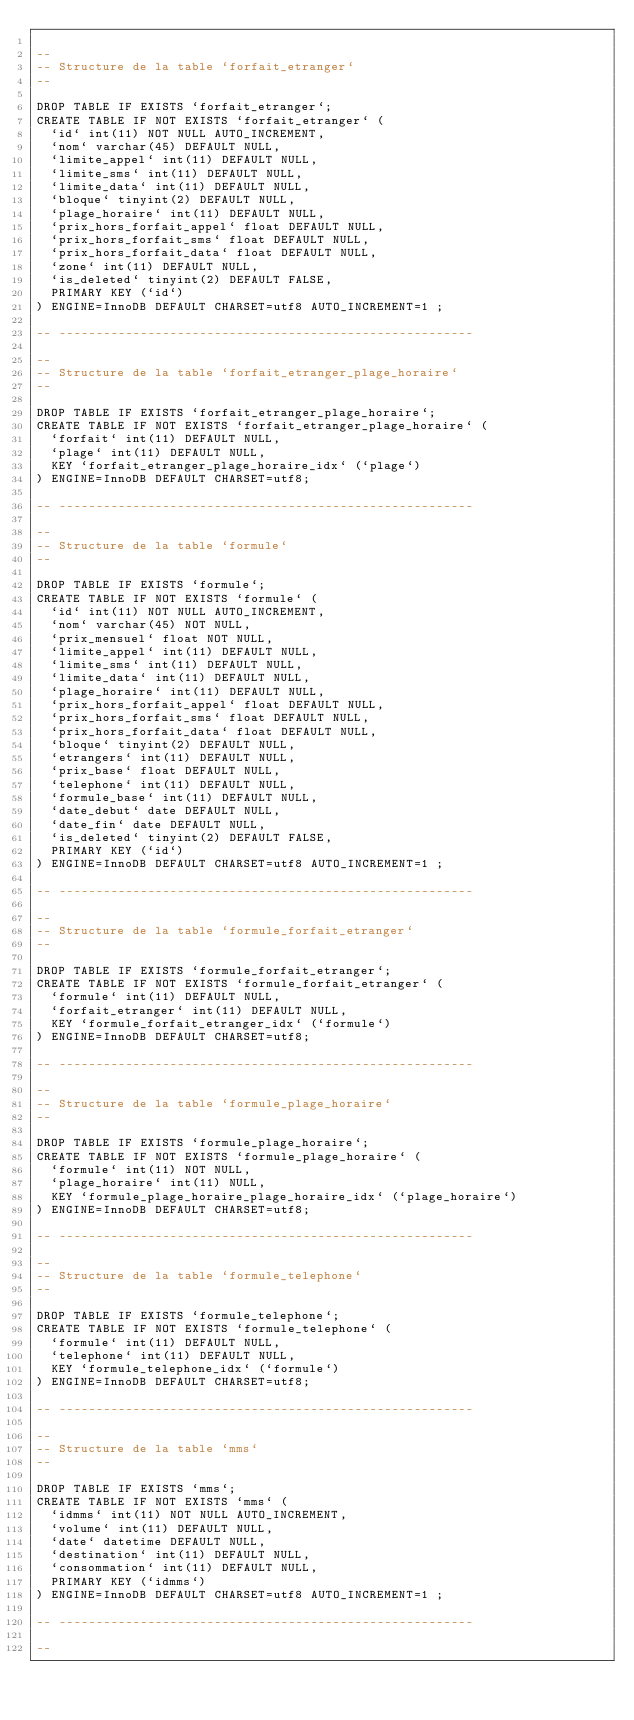Convert code to text. <code><loc_0><loc_0><loc_500><loc_500><_SQL_>
--
-- Structure de la table `forfait_etranger`
--

DROP TABLE IF EXISTS `forfait_etranger`;
CREATE TABLE IF NOT EXISTS `forfait_etranger` (
  `id` int(11) NOT NULL AUTO_INCREMENT,
  `nom` varchar(45) DEFAULT NULL,
  `limite_appel` int(11) DEFAULT NULL,
  `limite_sms` int(11) DEFAULT NULL,
  `limite_data` int(11) DEFAULT NULL,
  `bloque` tinyint(2) DEFAULT NULL,
  `plage_horaire` int(11) DEFAULT NULL,
  `prix_hors_forfait_appel` float DEFAULT NULL,
  `prix_hors_forfait_sms` float DEFAULT NULL,
  `prix_hors_forfait_data` float DEFAULT NULL,
  `zone` int(11) DEFAULT NULL,
  `is_deleted` tinyint(2) DEFAULT FALSE,
  PRIMARY KEY (`id`)
) ENGINE=InnoDB DEFAULT CHARSET=utf8 AUTO_INCREMENT=1 ;

-- --------------------------------------------------------

--
-- Structure de la table `forfait_etranger_plage_horaire`
--

DROP TABLE IF EXISTS `forfait_etranger_plage_horaire`;
CREATE TABLE IF NOT EXISTS `forfait_etranger_plage_horaire` (
  `forfait` int(11) DEFAULT NULL,
  `plage` int(11) DEFAULT NULL,
  KEY `forfait_etranger_plage_horaire_idx` (`plage`)
) ENGINE=InnoDB DEFAULT CHARSET=utf8;

-- --------------------------------------------------------

--
-- Structure de la table `formule`
--

DROP TABLE IF EXISTS `formule`;
CREATE TABLE IF NOT EXISTS `formule` (
  `id` int(11) NOT NULL AUTO_INCREMENT,
  `nom` varchar(45) NOT NULL,
  `prix_mensuel` float NOT NULL,
  `limite_appel` int(11) DEFAULT NULL,
  `limite_sms` int(11) DEFAULT NULL,
  `limite_data` int(11) DEFAULT NULL,
  `plage_horaire` int(11) DEFAULT NULL,
  `prix_hors_forfait_appel` float DEFAULT NULL,
  `prix_hors_forfait_sms` float DEFAULT NULL,
  `prix_hors_forfait_data` float DEFAULT NULL,
  `bloque` tinyint(2) DEFAULT NULL,
  `etrangers` int(11) DEFAULT NULL,
  `prix_base` float DEFAULT NULL,
  `telephone` int(11) DEFAULT NULL,
  `formule_base` int(11) DEFAULT NULL,
  `date_debut` date DEFAULT NULL,
  `date_fin` date DEFAULT NULL,
  `is_deleted` tinyint(2) DEFAULT FALSE,
  PRIMARY KEY (`id`)
) ENGINE=InnoDB DEFAULT CHARSET=utf8 AUTO_INCREMENT=1 ;

-- --------------------------------------------------------

--
-- Structure de la table `formule_forfait_etranger`
--

DROP TABLE IF EXISTS `formule_forfait_etranger`;
CREATE TABLE IF NOT EXISTS `formule_forfait_etranger` (
  `formule` int(11) DEFAULT NULL,
  `forfait_etranger` int(11) DEFAULT NULL,
  KEY `formule_forfait_etranger_idx` (`formule`)
) ENGINE=InnoDB DEFAULT CHARSET=utf8;

-- --------------------------------------------------------

--
-- Structure de la table `formule_plage_horaire`
--

DROP TABLE IF EXISTS `formule_plage_horaire`;
CREATE TABLE IF NOT EXISTS `formule_plage_horaire` (
  `formule` int(11) NOT NULL,
  `plage_horaire` int(11) NULL,
  KEY `formule_plage_horaire_plage_horaire_idx` (`plage_horaire`)
) ENGINE=InnoDB DEFAULT CHARSET=utf8;

-- --------------------------------------------------------

--
-- Structure de la table `formule_telephone`
--

DROP TABLE IF EXISTS `formule_telephone`;
CREATE TABLE IF NOT EXISTS `formule_telephone` (
  `formule` int(11) DEFAULT NULL,
  `telephone` int(11) DEFAULT NULL,
  KEY `formule_telephone_idx` (`formule`)
) ENGINE=InnoDB DEFAULT CHARSET=utf8;

-- --------------------------------------------------------

--
-- Structure de la table `mms`
--

DROP TABLE IF EXISTS `mms`;
CREATE TABLE IF NOT EXISTS `mms` (
  `idmms` int(11) NOT NULL AUTO_INCREMENT,
  `volume` int(11) DEFAULT NULL,
  `date` datetime DEFAULT NULL,
  `destination` int(11) DEFAULT NULL,
  `consommation` int(11) DEFAULT NULL,
  PRIMARY KEY (`idmms`)
) ENGINE=InnoDB DEFAULT CHARSET=utf8 AUTO_INCREMENT=1 ;

-- --------------------------------------------------------

--</code> 